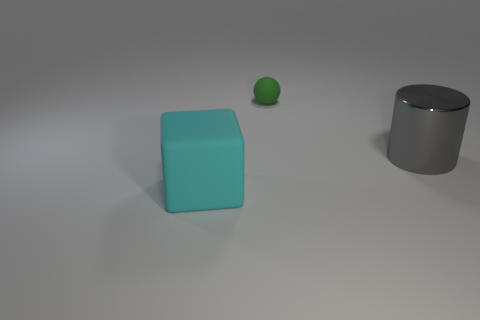Is the number of tiny green matte things that are right of the small rubber object less than the number of small green objects that are left of the cylinder?
Keep it short and to the point. Yes. Are the tiny thing and the gray object made of the same material?
Your response must be concise. No. There is a object that is both in front of the green rubber thing and to the right of the large cyan cube; what size is it?
Your answer should be very brief. Large. What is the shape of the gray metal thing that is the same size as the cyan block?
Keep it short and to the point. Cylinder. There is a thing to the right of the rubber thing that is behind the big thing that is in front of the gray thing; what is it made of?
Provide a short and direct response. Metal. What number of other things are the same material as the large gray cylinder?
Offer a terse response. 0. Do the thing that is behind the shiny thing and the big object that is in front of the gray shiny cylinder have the same material?
Provide a short and direct response. Yes. There is another thing that is the same material as the green thing; what shape is it?
Offer a very short reply. Cube. What number of cyan objects are there?
Keep it short and to the point. 1. There is a object that is left of the shiny cylinder and behind the big cyan cube; what shape is it?
Provide a short and direct response. Sphere. 